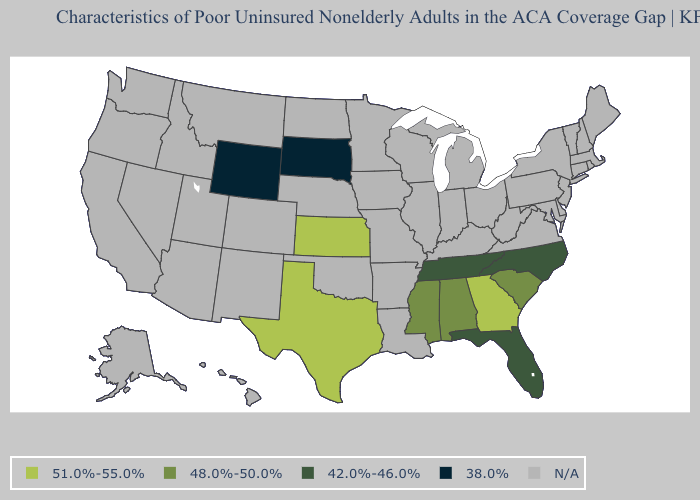Name the states that have a value in the range 51.0%-55.0%?
Give a very brief answer. Georgia, Kansas, Texas. Which states have the highest value in the USA?
Short answer required. Georgia, Kansas, Texas. How many symbols are there in the legend?
Quick response, please. 5. What is the value of New Mexico?
Short answer required. N/A. Which states have the lowest value in the USA?
Quick response, please. South Dakota, Wyoming. Which states have the lowest value in the West?
Concise answer only. Wyoming. Name the states that have a value in the range 48.0%-50.0%?
Quick response, please. Alabama, Mississippi, South Carolina. Name the states that have a value in the range 51.0%-55.0%?
Quick response, please. Georgia, Kansas, Texas. What is the value of New York?
Write a very short answer. N/A. How many symbols are there in the legend?
Give a very brief answer. 5. What is the value of Mississippi?
Answer briefly. 48.0%-50.0%. Name the states that have a value in the range 51.0%-55.0%?
Quick response, please. Georgia, Kansas, Texas. 